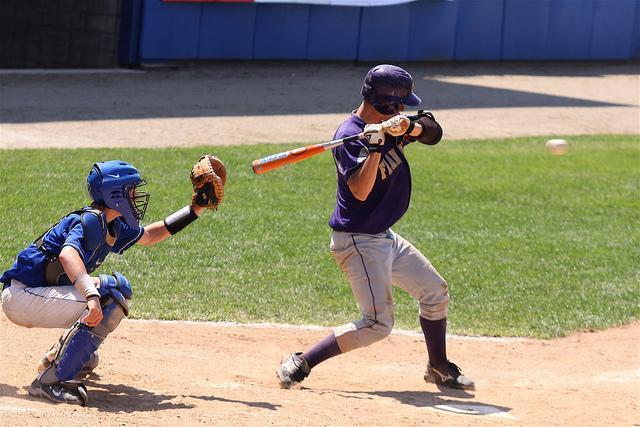How many people can you see?
Give a very brief answer. 2. How many chairs don't have a dog on them?
Give a very brief answer. 0. 